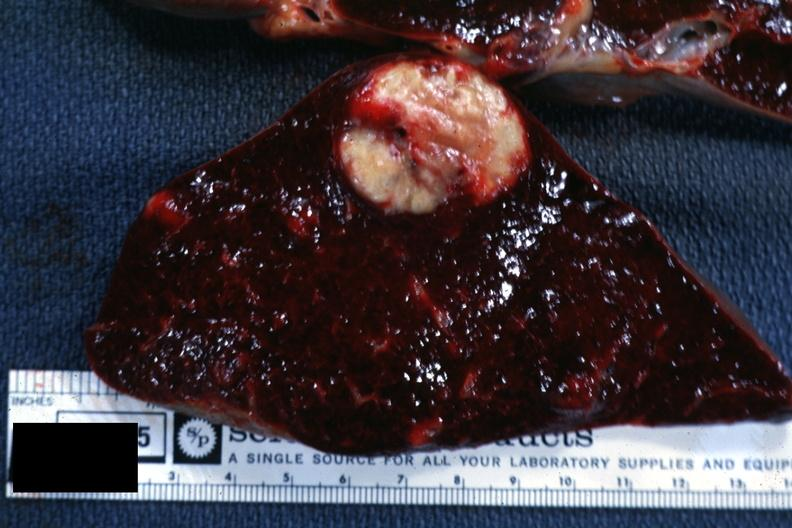s hematologic present?
Answer the question using a single word or phrase. Yes 